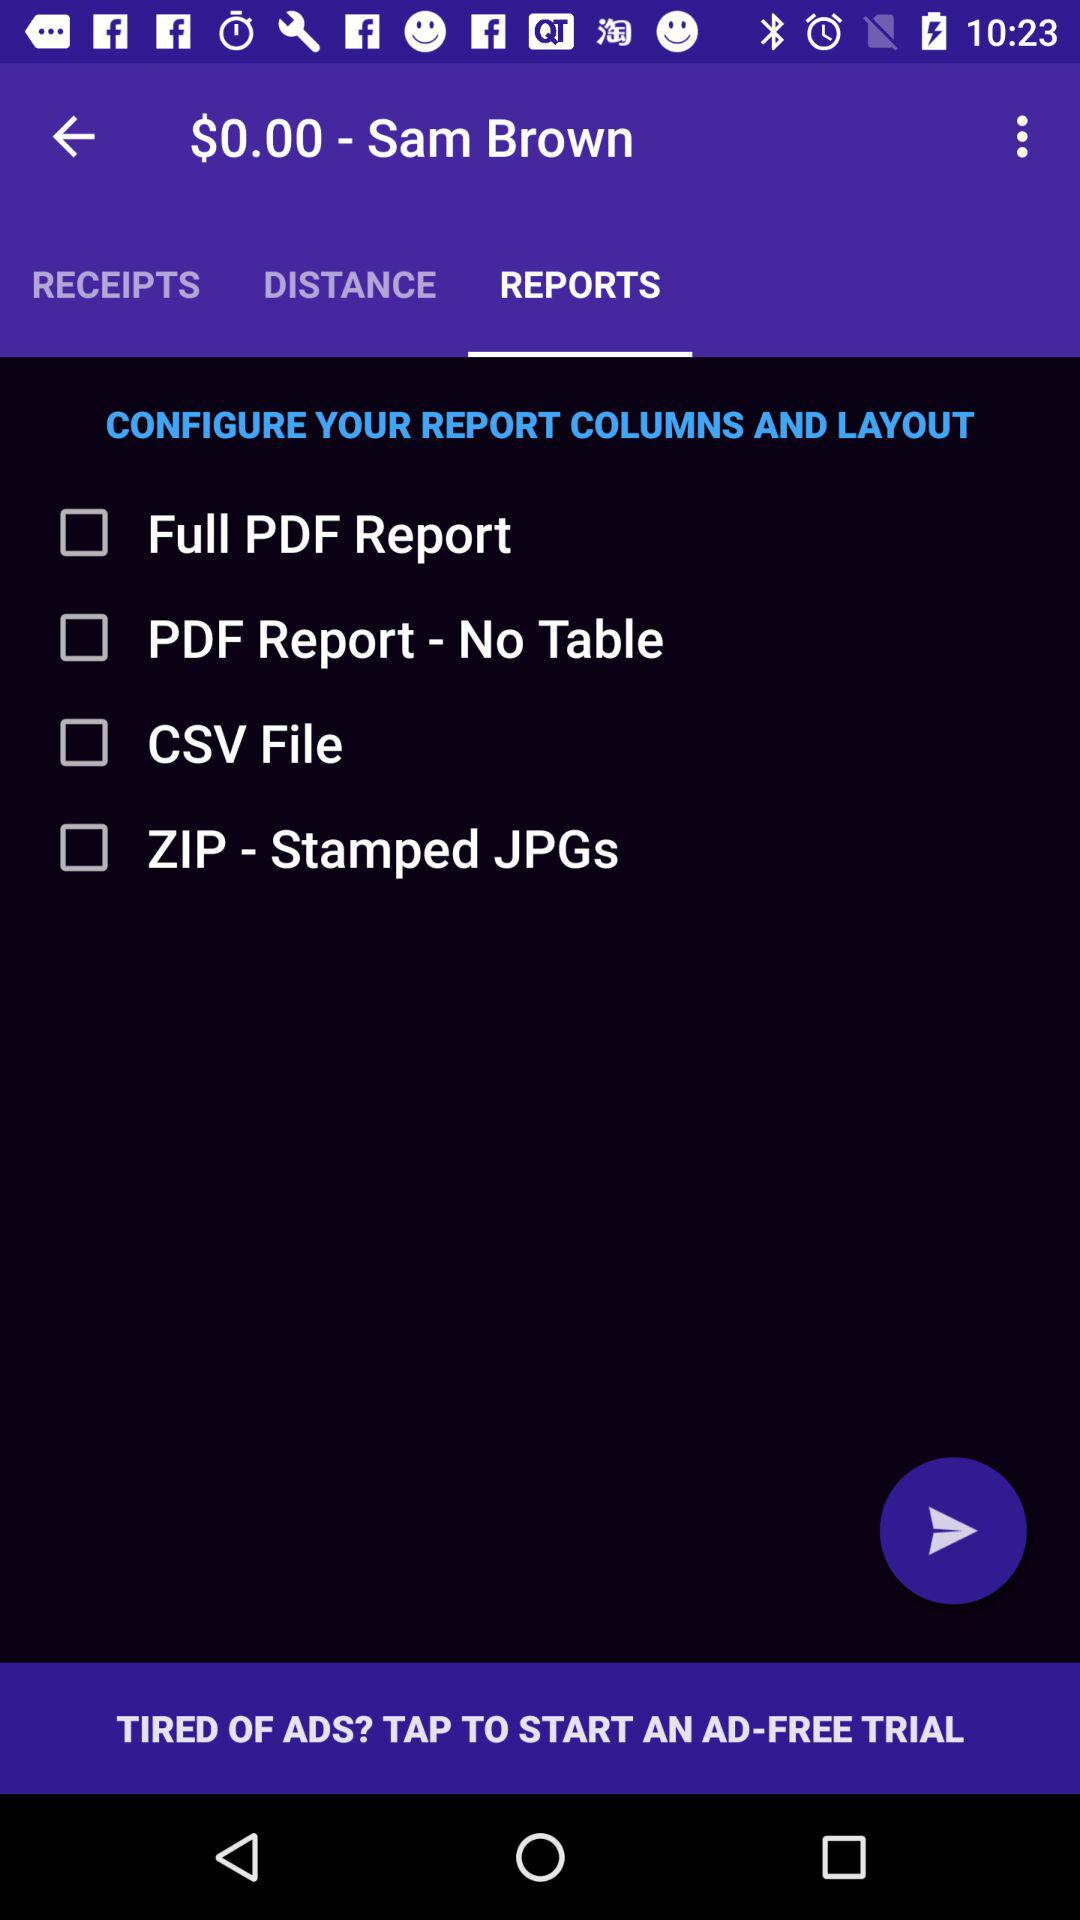What is the name of the person? The name of the person is Sam Brown. 